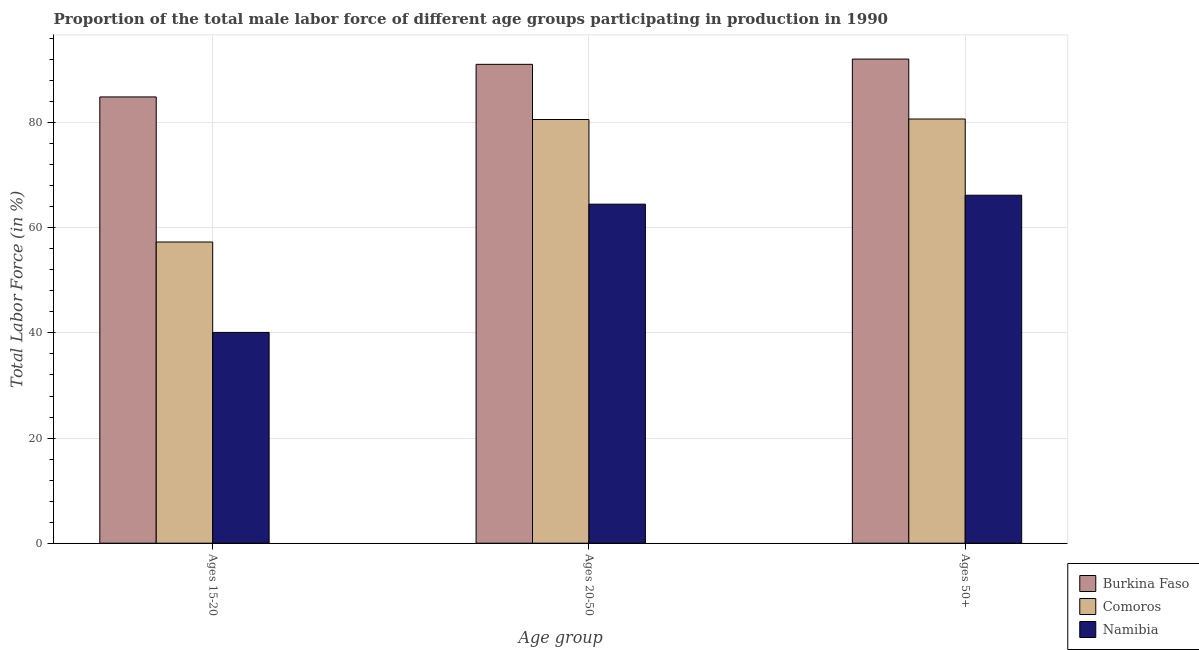Are the number of bars per tick equal to the number of legend labels?
Give a very brief answer. Yes. What is the label of the 1st group of bars from the left?
Your response must be concise. Ages 15-20. What is the percentage of male labor force above age 50 in Burkina Faso?
Your answer should be very brief. 92.1. Across all countries, what is the maximum percentage of male labor force within the age group 20-50?
Your answer should be very brief. 91.1. Across all countries, what is the minimum percentage of male labor force above age 50?
Offer a terse response. 66.2. In which country was the percentage of male labor force within the age group 15-20 maximum?
Your answer should be very brief. Burkina Faso. In which country was the percentage of male labor force above age 50 minimum?
Offer a very short reply. Namibia. What is the total percentage of male labor force above age 50 in the graph?
Your answer should be compact. 239. What is the difference between the percentage of male labor force above age 50 in Comoros and that in Namibia?
Your answer should be very brief. 14.5. What is the difference between the percentage of male labor force within the age group 15-20 in Burkina Faso and the percentage of male labor force above age 50 in Comoros?
Your response must be concise. 4.2. What is the average percentage of male labor force above age 50 per country?
Make the answer very short. 79.67. What is the difference between the percentage of male labor force within the age group 20-50 and percentage of male labor force within the age group 15-20 in Comoros?
Ensure brevity in your answer.  23.3. In how many countries, is the percentage of male labor force above age 50 greater than 88 %?
Make the answer very short. 1. What is the ratio of the percentage of male labor force within the age group 20-50 in Comoros to that in Burkina Faso?
Make the answer very short. 0.88. Is the percentage of male labor force above age 50 in Burkina Faso less than that in Namibia?
Your answer should be compact. No. Is the difference between the percentage of male labor force within the age group 15-20 in Burkina Faso and Namibia greater than the difference between the percentage of male labor force within the age group 20-50 in Burkina Faso and Namibia?
Offer a very short reply. Yes. What is the difference between the highest and the lowest percentage of male labor force above age 50?
Offer a very short reply. 25.9. What does the 3rd bar from the left in Ages 20-50 represents?
Offer a terse response. Namibia. What does the 3rd bar from the right in Ages 15-20 represents?
Your response must be concise. Burkina Faso. How many bars are there?
Give a very brief answer. 9. How many countries are there in the graph?
Make the answer very short. 3. Where does the legend appear in the graph?
Give a very brief answer. Bottom right. How are the legend labels stacked?
Make the answer very short. Vertical. What is the title of the graph?
Give a very brief answer. Proportion of the total male labor force of different age groups participating in production in 1990. What is the label or title of the X-axis?
Make the answer very short. Age group. What is the label or title of the Y-axis?
Your answer should be compact. Total Labor Force (in %). What is the Total Labor Force (in %) in Burkina Faso in Ages 15-20?
Make the answer very short. 84.9. What is the Total Labor Force (in %) in Comoros in Ages 15-20?
Ensure brevity in your answer.  57.3. What is the Total Labor Force (in %) in Namibia in Ages 15-20?
Your response must be concise. 40.1. What is the Total Labor Force (in %) in Burkina Faso in Ages 20-50?
Keep it short and to the point. 91.1. What is the Total Labor Force (in %) in Comoros in Ages 20-50?
Keep it short and to the point. 80.6. What is the Total Labor Force (in %) in Namibia in Ages 20-50?
Ensure brevity in your answer.  64.5. What is the Total Labor Force (in %) in Burkina Faso in Ages 50+?
Your response must be concise. 92.1. What is the Total Labor Force (in %) in Comoros in Ages 50+?
Ensure brevity in your answer.  80.7. What is the Total Labor Force (in %) in Namibia in Ages 50+?
Your response must be concise. 66.2. Across all Age group, what is the maximum Total Labor Force (in %) in Burkina Faso?
Provide a short and direct response. 92.1. Across all Age group, what is the maximum Total Labor Force (in %) in Comoros?
Make the answer very short. 80.7. Across all Age group, what is the maximum Total Labor Force (in %) in Namibia?
Your answer should be very brief. 66.2. Across all Age group, what is the minimum Total Labor Force (in %) of Burkina Faso?
Your answer should be very brief. 84.9. Across all Age group, what is the minimum Total Labor Force (in %) in Comoros?
Provide a succinct answer. 57.3. Across all Age group, what is the minimum Total Labor Force (in %) in Namibia?
Keep it short and to the point. 40.1. What is the total Total Labor Force (in %) in Burkina Faso in the graph?
Keep it short and to the point. 268.1. What is the total Total Labor Force (in %) in Comoros in the graph?
Offer a terse response. 218.6. What is the total Total Labor Force (in %) in Namibia in the graph?
Your answer should be compact. 170.8. What is the difference between the Total Labor Force (in %) of Comoros in Ages 15-20 and that in Ages 20-50?
Give a very brief answer. -23.3. What is the difference between the Total Labor Force (in %) in Namibia in Ages 15-20 and that in Ages 20-50?
Provide a succinct answer. -24.4. What is the difference between the Total Labor Force (in %) in Burkina Faso in Ages 15-20 and that in Ages 50+?
Offer a very short reply. -7.2. What is the difference between the Total Labor Force (in %) in Comoros in Ages 15-20 and that in Ages 50+?
Give a very brief answer. -23.4. What is the difference between the Total Labor Force (in %) of Namibia in Ages 15-20 and that in Ages 50+?
Offer a terse response. -26.1. What is the difference between the Total Labor Force (in %) of Burkina Faso in Ages 20-50 and that in Ages 50+?
Your answer should be very brief. -1. What is the difference between the Total Labor Force (in %) of Comoros in Ages 20-50 and that in Ages 50+?
Make the answer very short. -0.1. What is the difference between the Total Labor Force (in %) of Burkina Faso in Ages 15-20 and the Total Labor Force (in %) of Namibia in Ages 20-50?
Provide a succinct answer. 20.4. What is the difference between the Total Labor Force (in %) of Burkina Faso in Ages 15-20 and the Total Labor Force (in %) of Namibia in Ages 50+?
Your answer should be compact. 18.7. What is the difference between the Total Labor Force (in %) of Comoros in Ages 15-20 and the Total Labor Force (in %) of Namibia in Ages 50+?
Make the answer very short. -8.9. What is the difference between the Total Labor Force (in %) in Burkina Faso in Ages 20-50 and the Total Labor Force (in %) in Comoros in Ages 50+?
Offer a very short reply. 10.4. What is the difference between the Total Labor Force (in %) of Burkina Faso in Ages 20-50 and the Total Labor Force (in %) of Namibia in Ages 50+?
Give a very brief answer. 24.9. What is the average Total Labor Force (in %) of Burkina Faso per Age group?
Your response must be concise. 89.37. What is the average Total Labor Force (in %) in Comoros per Age group?
Make the answer very short. 72.87. What is the average Total Labor Force (in %) in Namibia per Age group?
Provide a short and direct response. 56.93. What is the difference between the Total Labor Force (in %) in Burkina Faso and Total Labor Force (in %) in Comoros in Ages 15-20?
Make the answer very short. 27.6. What is the difference between the Total Labor Force (in %) of Burkina Faso and Total Labor Force (in %) of Namibia in Ages 15-20?
Provide a short and direct response. 44.8. What is the difference between the Total Labor Force (in %) in Comoros and Total Labor Force (in %) in Namibia in Ages 15-20?
Offer a terse response. 17.2. What is the difference between the Total Labor Force (in %) of Burkina Faso and Total Labor Force (in %) of Comoros in Ages 20-50?
Provide a short and direct response. 10.5. What is the difference between the Total Labor Force (in %) in Burkina Faso and Total Labor Force (in %) in Namibia in Ages 20-50?
Your response must be concise. 26.6. What is the difference between the Total Labor Force (in %) of Burkina Faso and Total Labor Force (in %) of Namibia in Ages 50+?
Ensure brevity in your answer.  25.9. What is the difference between the Total Labor Force (in %) in Comoros and Total Labor Force (in %) in Namibia in Ages 50+?
Offer a terse response. 14.5. What is the ratio of the Total Labor Force (in %) in Burkina Faso in Ages 15-20 to that in Ages 20-50?
Your answer should be compact. 0.93. What is the ratio of the Total Labor Force (in %) in Comoros in Ages 15-20 to that in Ages 20-50?
Offer a very short reply. 0.71. What is the ratio of the Total Labor Force (in %) of Namibia in Ages 15-20 to that in Ages 20-50?
Ensure brevity in your answer.  0.62. What is the ratio of the Total Labor Force (in %) of Burkina Faso in Ages 15-20 to that in Ages 50+?
Ensure brevity in your answer.  0.92. What is the ratio of the Total Labor Force (in %) in Comoros in Ages 15-20 to that in Ages 50+?
Your answer should be very brief. 0.71. What is the ratio of the Total Labor Force (in %) of Namibia in Ages 15-20 to that in Ages 50+?
Your answer should be compact. 0.61. What is the ratio of the Total Labor Force (in %) in Comoros in Ages 20-50 to that in Ages 50+?
Provide a short and direct response. 1. What is the ratio of the Total Labor Force (in %) in Namibia in Ages 20-50 to that in Ages 50+?
Provide a short and direct response. 0.97. What is the difference between the highest and the second highest Total Labor Force (in %) in Burkina Faso?
Your answer should be very brief. 1. What is the difference between the highest and the second highest Total Labor Force (in %) in Comoros?
Ensure brevity in your answer.  0.1. What is the difference between the highest and the second highest Total Labor Force (in %) of Namibia?
Provide a succinct answer. 1.7. What is the difference between the highest and the lowest Total Labor Force (in %) in Burkina Faso?
Provide a short and direct response. 7.2. What is the difference between the highest and the lowest Total Labor Force (in %) of Comoros?
Offer a terse response. 23.4. What is the difference between the highest and the lowest Total Labor Force (in %) of Namibia?
Provide a succinct answer. 26.1. 